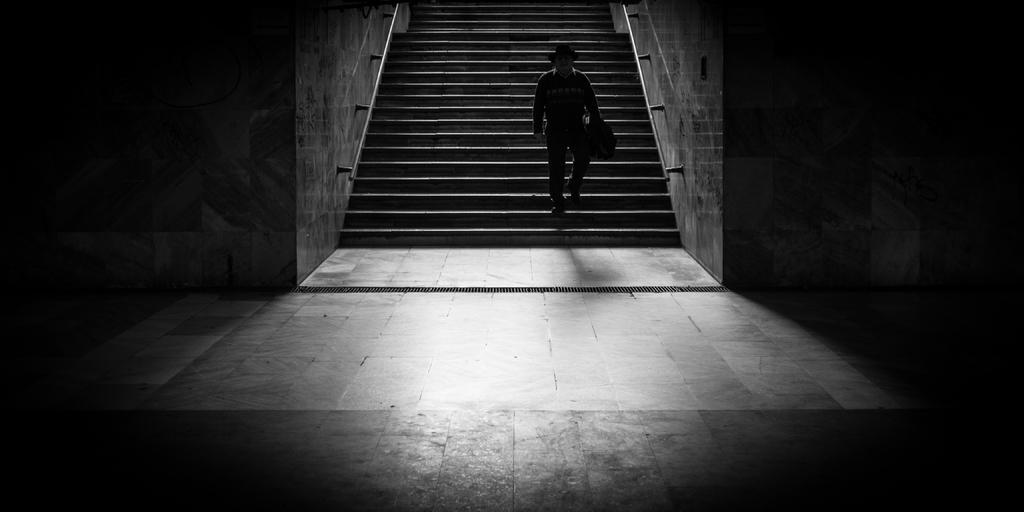Please provide a concise description of this image. In the picture I can see a person, steps, a wall and some other objects. This picture is black and white in color. 